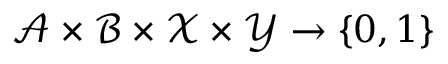<formula> <loc_0><loc_0><loc_500><loc_500>\mathcal { A } \times \mathcal { B } \times \mathcal { X } \times \mathcal { Y } \rightarrow \{ 0 , 1 \}</formula> 